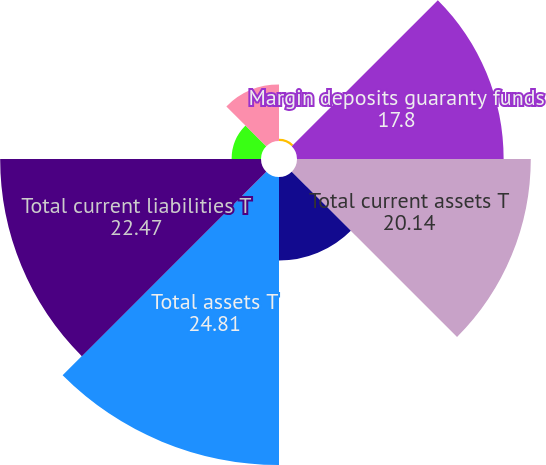Convert chart. <chart><loc_0><loc_0><loc_500><loc_500><pie_chart><fcel>Cash and cash equivalents<fcel>Margin deposits guaranty funds<fcel>Total current assets T<fcel>Goodwill and other intangible<fcel>Total assets T<fcel>Total current liabilities T<fcel>Short-term and long-term<fcel>Equity (2)<nl><fcel>0.19%<fcel>17.8%<fcel>20.14%<fcel>7.2%<fcel>24.81%<fcel>22.47%<fcel>2.53%<fcel>4.86%<nl></chart> 